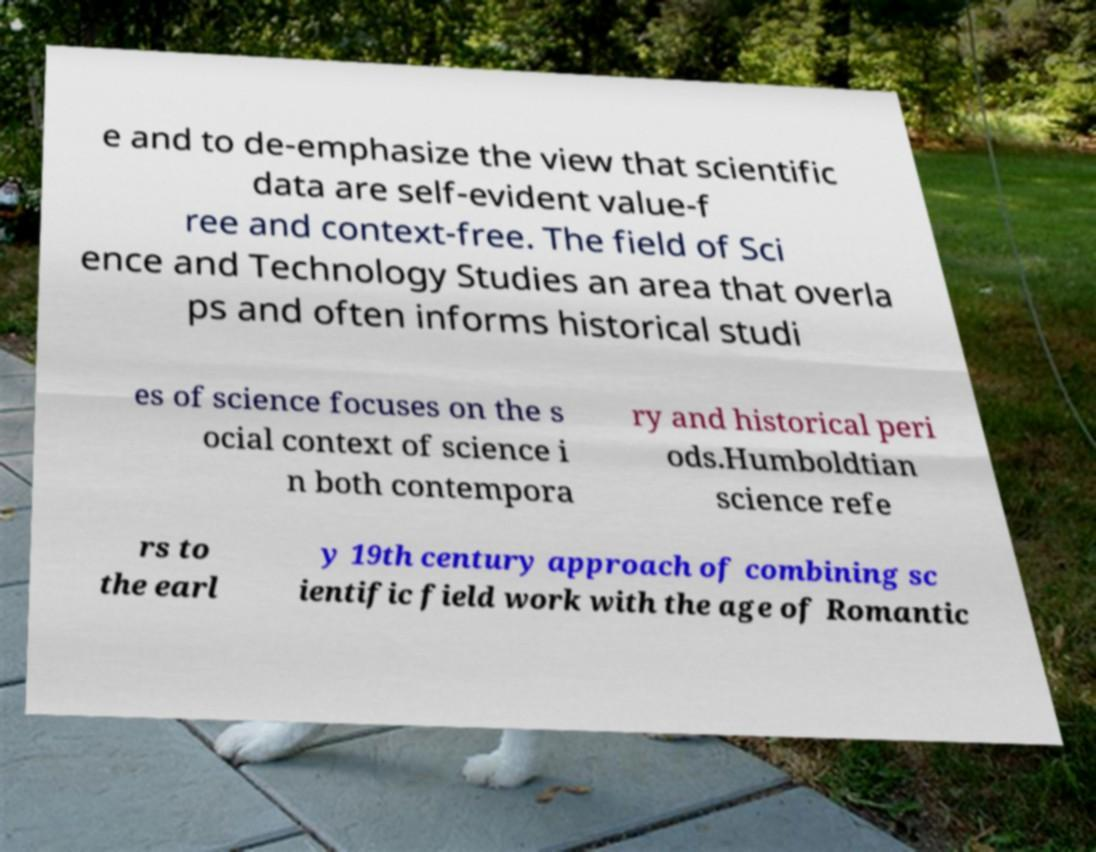For documentation purposes, I need the text within this image transcribed. Could you provide that? e and to de-emphasize the view that scientific data are self-evident value-f ree and context-free. The field of Sci ence and Technology Studies an area that overla ps and often informs historical studi es of science focuses on the s ocial context of science i n both contempora ry and historical peri ods.Humboldtian science refe rs to the earl y 19th century approach of combining sc ientific field work with the age of Romantic 